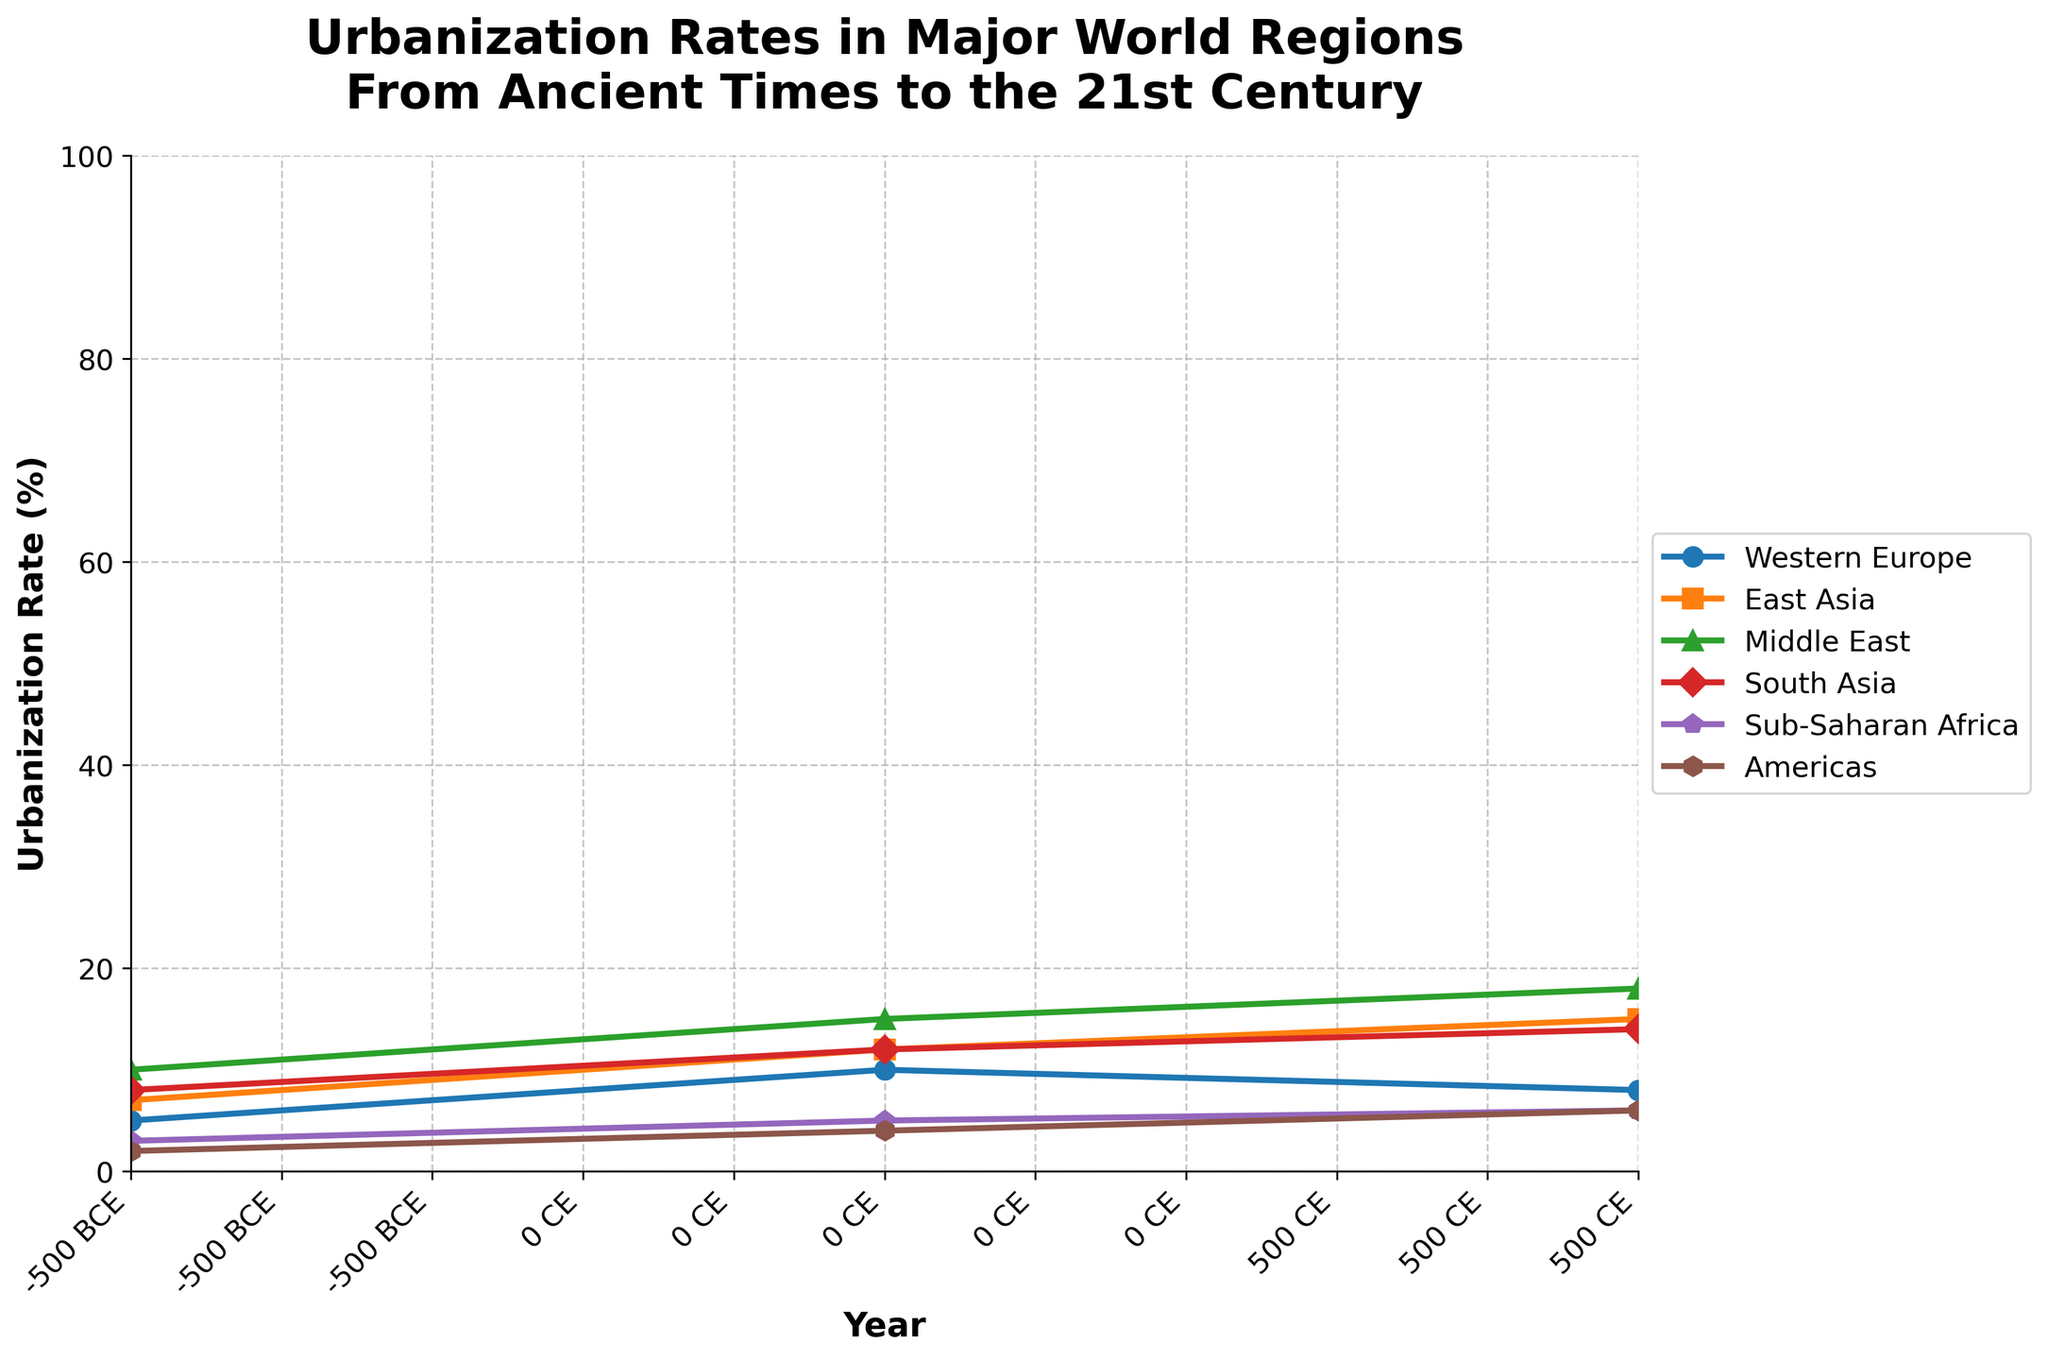Which region had the highest urbanization rate in 1500 CE? Look at the year 1500 CE on the x-axis and compare the urbanization rates of the regions. The region with the highest point on the chart is East Asia.
Answer: East Asia Which two regions have a similar urbanization rate around the year 2000 CE? Look at the year 2000 CE on the x-axis and find two regions with urbanization rates that are very close together. Western Europe and the Americas both have 75%.
Answer: Western Europe, Americas What is the difference in urbanization rates between Sub-Saharan Africa and East Asia in 2020 CE? Look at the year 2020 CE on the x-axis. Sub-Saharan Africa has an urbanization rate of 40%, and East Asia has 65%. The difference is calculated as 65% - 40% = 25%.
Answer: 25% How did the urbanization rate of the Middle East change between 0 CE and 1950 CE? Identify the points for the Middle East at 0 CE and 1950 CE. The rates are 15% at 0 CE and 35% at 1950 CE, so the change is 35% - 15% = 20%.
Answer: Increased by 20% Which region had the steepest increase in urbanization rate between 1900 CE and 1950 CE? Compare the slopes of the lines for each region between 1900 CE and 1950 CE. The steepest line indicates the fastest increase. The Americas increased from 30% to 45%, a change of 15%, the highest among the regions.
Answer: Americas What was the urbanization rate trend in South Asia from 1000 CE to 1800 CE? Observe the urbanization rate for South Asia from 1000 CE (17%) to 1800 CE (24%). The rate increases steadily over this period.
Answer: Increasing Compare the urbanization rates of Western Europe and East Asia in 500 CE. Which was higher, and by how much? Look at the year 500 CE and compare the rates for Western Europe (8%) and East Asia (15%). The difference is calculated as 15% - 8% = 7%.
Answer: East Asia, by 7% What is the average urbanization rate of the Americas across all given years? Sum the urbanization rates of the Americas (2, 4, 6, 8, 10, 12, 15, 30, 45, 75, 80) and divide by the number of data points, which is 11. The sum is 287, so the average is 287/11 ≈ 26.1%.
Answer: 26.1% Which region had the lowest urbanization rate in 0 CE and what was it? Look at the year 0 CE and compare the urbanization rates. The region with the lowest rate is the Americas at 4%.
Answer: Americas How did urbanization rates in Sub-Saharan Africa change from 1500 CE to 1700 CE and then to 1900 CE? Identify the urbanization rates for Sub-Saharan Africa at 1500 CE (10%), 1700 CE (12%), and 1900 CE (16%). From 1500 CE to 1700 CE, the rate increased by 2%, and from 1700 CE to 1900 CE, it increased by 4%.
Answer: Increased by 2% and then by 4% 